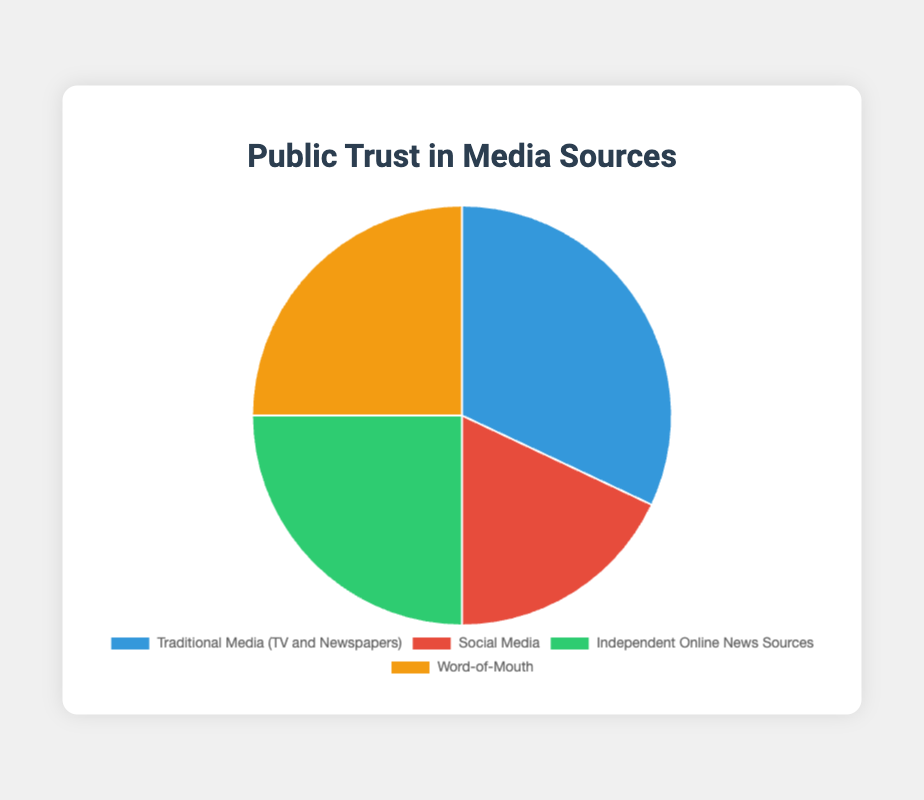What proportion of public trust is combined for Independent Online News Sources and Word-of-Mouth? Sum the percentages for Independent Online News Sources (25%) and Word-of-Mouth (25%). The combined proportion is 25% + 25% = 50%.
Answer: 50% Which media source has the highest public trust? Compare the trust percentages: Traditional Media (TV and Newspapers) has 32%, Social Media has 18%, Independent Online News Sources has 25%, and Word-of-Mouth has 25%. Traditional Media has the highest trust at 32%.
Answer: Traditional Media Which media sources have equal levels of public trust? Look at the trust percentages: Independent Online News Sources and Word-of-Mouth both have 25%.
Answer: Independent Online News Sources and Word-of-Mouth How much higher is the trust in Traditional Media compared to Social Media? Subtract the trust percentage of Social Media (18%) from Traditional Media (32%). The difference is 32% - 18% = 14%.
Answer: 14% What is the average trust percentage across all media sources? Add the trust percentages: 32% (Traditional Media) + 18% (Social Media) + 25% (Independent Online News Sources) + 25% (Word-of-Mouth) = 100%. Divide by the number of sources: 100% ÷ 4 = 25%.
Answer: 25% What fraction of the public does not trust Social Media as a source? Subtract the trust percentage of Social Media (18%) from 100%. The fraction is 100% - 18% = 82%.
Answer: 82% Which media source is less trusted than all others? Compare the trust percentages: Social Media has the lowest trust percentage at 18%.
Answer: Social Media What is the total percentage of trust in non-traditional media sources combined? Sum the trust percentages of Social Media (18%), Independent Online News Sources (25%), and Word-of-Mouth (25%). The total is 18% + 25% + 25% = 68%.
Answer: 68% What color represents the source with the highest trust percentage? According to the chart's description: Traditional Media (TV and Newspapers), which has the highest trust percentage (32%), is represented by blue.
Answer: Blue 